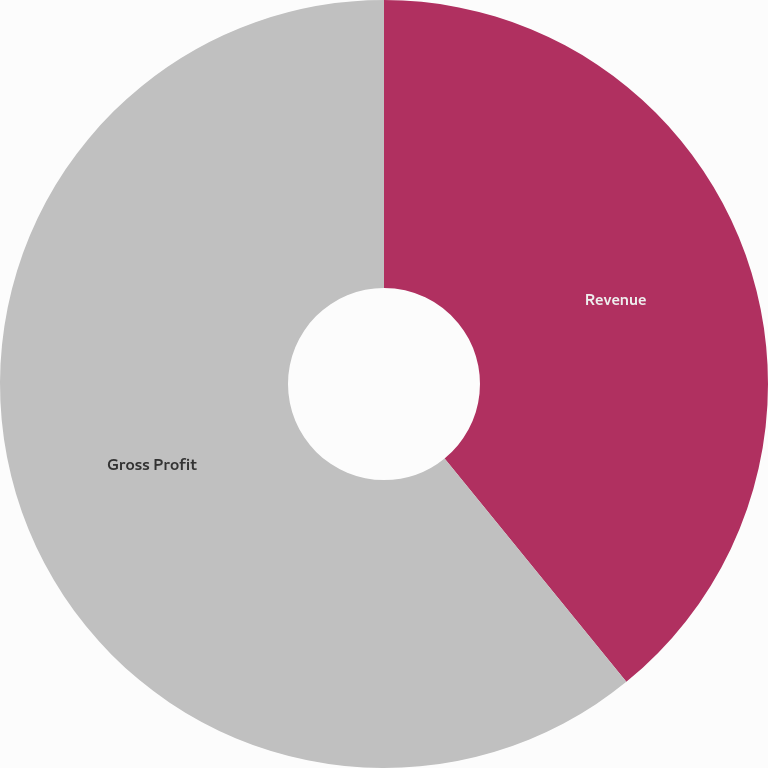Convert chart. <chart><loc_0><loc_0><loc_500><loc_500><pie_chart><fcel>Revenue<fcel>Gross Profit<nl><fcel>39.13%<fcel>60.87%<nl></chart> 